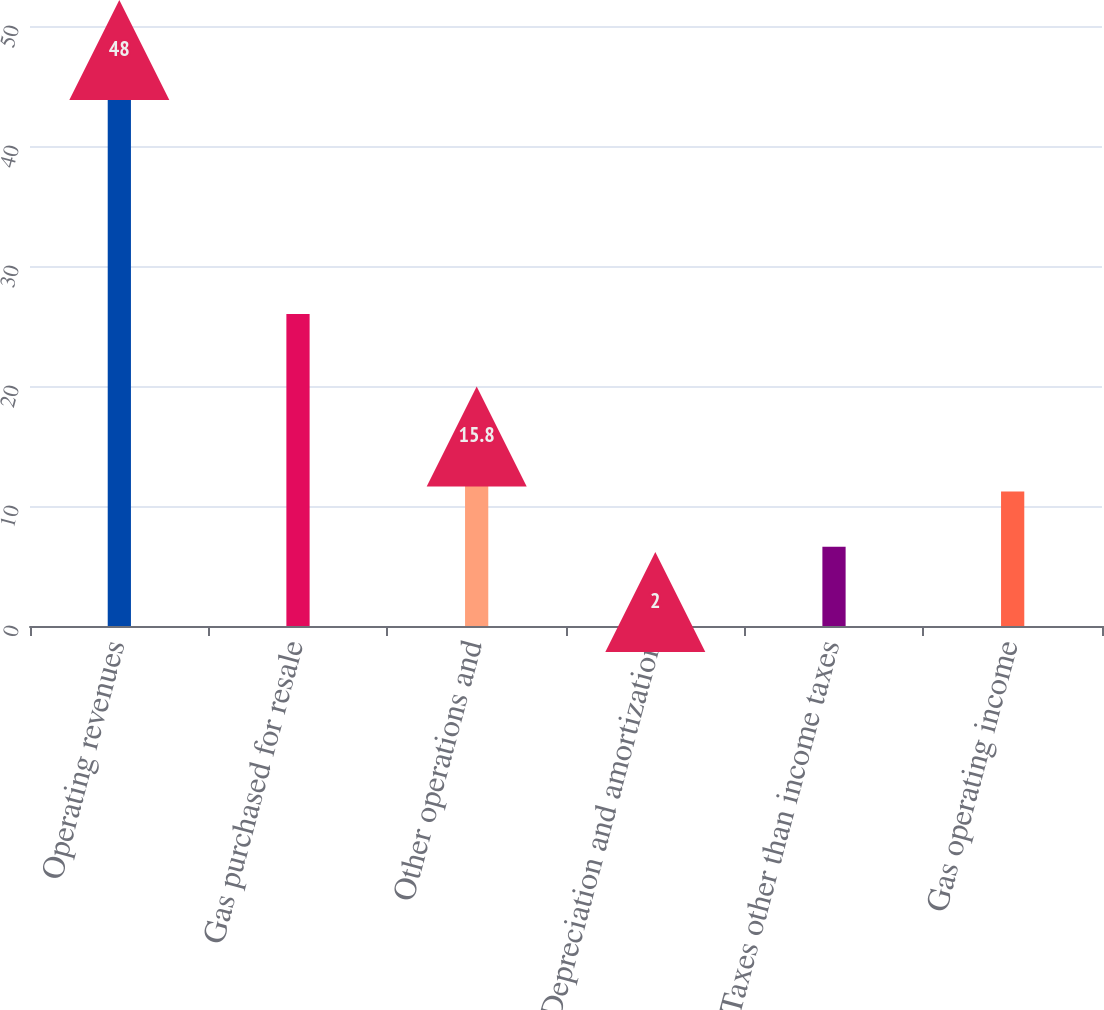Convert chart. <chart><loc_0><loc_0><loc_500><loc_500><bar_chart><fcel>Operating revenues<fcel>Gas purchased for resale<fcel>Other operations and<fcel>Depreciation and amortization<fcel>Taxes other than income taxes<fcel>Gas operating income<nl><fcel>48<fcel>26<fcel>15.8<fcel>2<fcel>6.6<fcel>11.2<nl></chart> 